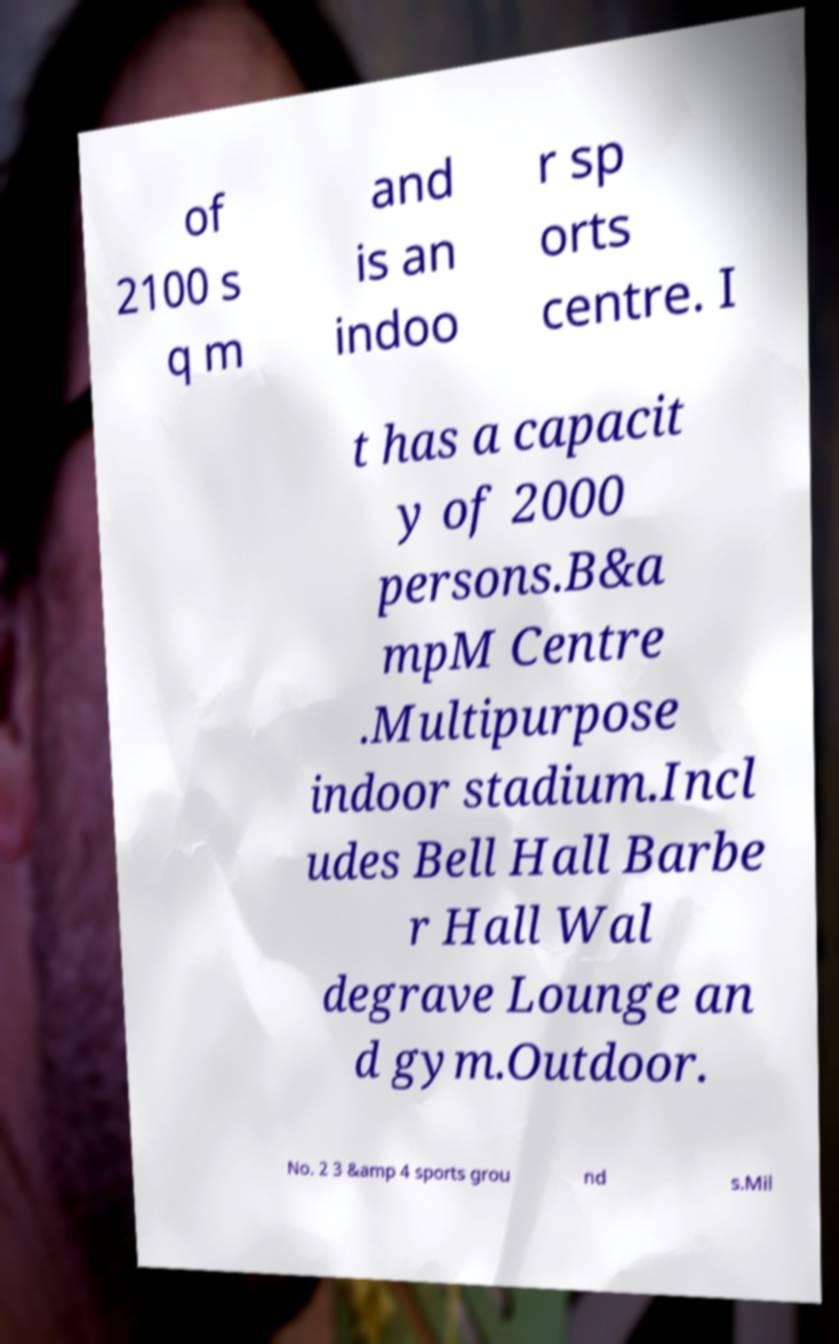For documentation purposes, I need the text within this image transcribed. Could you provide that? of 2100 s q m and is an indoo r sp orts centre. I t has a capacit y of 2000 persons.B&a mpM Centre .Multipurpose indoor stadium.Incl udes Bell Hall Barbe r Hall Wal degrave Lounge an d gym.Outdoor. No. 2 3 &amp 4 sports grou nd s.Mil 